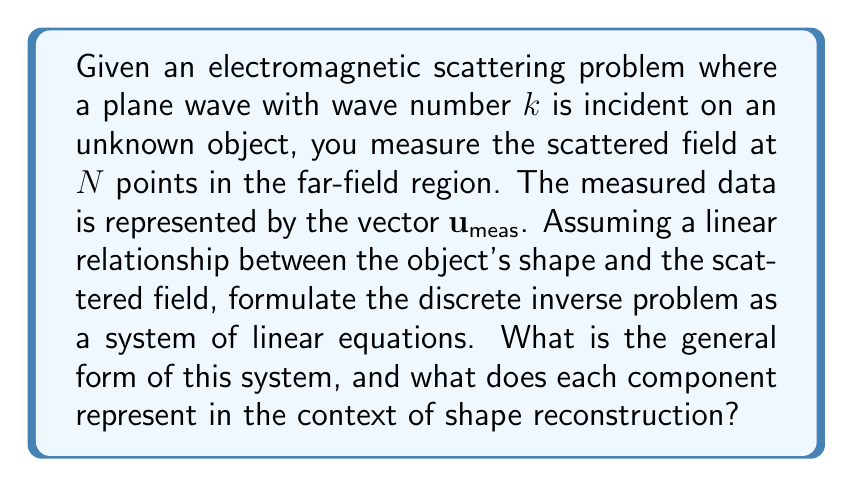Can you solve this math problem? To formulate the discrete inverse problem, we follow these steps:

1. Discretize the unknown object shape:
   Let $\mathbf{f}$ be a vector representing the discretized shape of the object. Each element of $\mathbf{f}$ corresponds to a point in the spatial domain.

2. Define the forward problem:
   The scattered field can be expressed as a linear function of the object shape:
   $$\mathbf{u} = A\mathbf{f}$$
   where $A$ is the forward operator that maps the object shape to the scattered field.

3. Incorporate measured data:
   The measured scattered field $\mathbf{u}_\text{meas}$ should ideally equal the computed scattered field $\mathbf{u}$:
   $$\mathbf{u}_\text{meas} = A\mathbf{f}$$

4. Formulate the inverse problem:
   The goal is to find $\mathbf{f}$ given $\mathbf{u}_\text{meas}$ and $A$. This can be written as a system of linear equations:
   $$A\mathbf{f} = \mathbf{u}_\text{meas}$$

In this formulation:
- $A$ is an $N \times M$ matrix, where $N$ is the number of measurement points and $M$ is the number of discretization points for the object shape.
- $\mathbf{f}$ is an $M \times 1$ vector representing the unknown object shape.
- $\mathbf{u}_\text{meas}$ is an $N \times 1$ vector of measured scattered field data.

Each row of $A$ represents the influence of the entire object shape on a single measurement point, while each column represents the influence of a single point in the object shape on all measurement points.
Answer: $A\mathbf{f} = \mathbf{u}_\text{meas}$, where $A$ is the forward operator, $\mathbf{f}$ is the unknown object shape, and $\mathbf{u}_\text{meas}$ is the measured scattered field. 